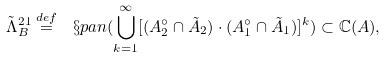Convert formula to latex. <formula><loc_0><loc_0><loc_500><loc_500>\tilde { \Lambda } _ { B } ^ { 2 1 } \overset { d e f } { = } \ \S p a n ( \underset { k = 1 } { \overset { \infty } { \bigcup } } [ ( A _ { 2 } ^ { \circ } \cap \tilde { A } _ { 2 } ) \cdot ( A _ { 1 } ^ { \circ } \cap \tilde { A } _ { 1 } ) ] ^ { k } ) \subset \mathbb { C } ( A ) ,</formula> 